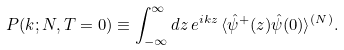Convert formula to latex. <formula><loc_0><loc_0><loc_500><loc_500>P ( k ; N , T = 0 ) \equiv \int ^ { \infty } _ { - \infty } d z \, e ^ { i k z } \, \langle \hat { \psi } ^ { + } ( z ) \hat { \psi } ( 0 ) \rangle ^ { ( N ) } .</formula> 